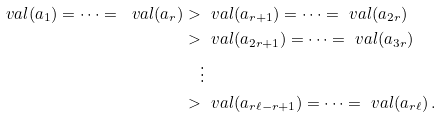<formula> <loc_0><loc_0><loc_500><loc_500>\ v a l ( a _ { 1 } ) = \dots = \ v a l ( a _ { r } ) & > \ v a l ( a _ { r + 1 } ) = \dots = \ v a l ( a _ { 2 r } ) \\ & > \ v a l ( a _ { 2 r + 1 } ) = \dots = \ v a l ( a _ { 3 r } ) \\ & \quad \vdots \\ & > \ v a l ( a _ { r \ell - r + 1 } ) = \dots = \ v a l ( a _ { r \ell } ) \, .</formula> 